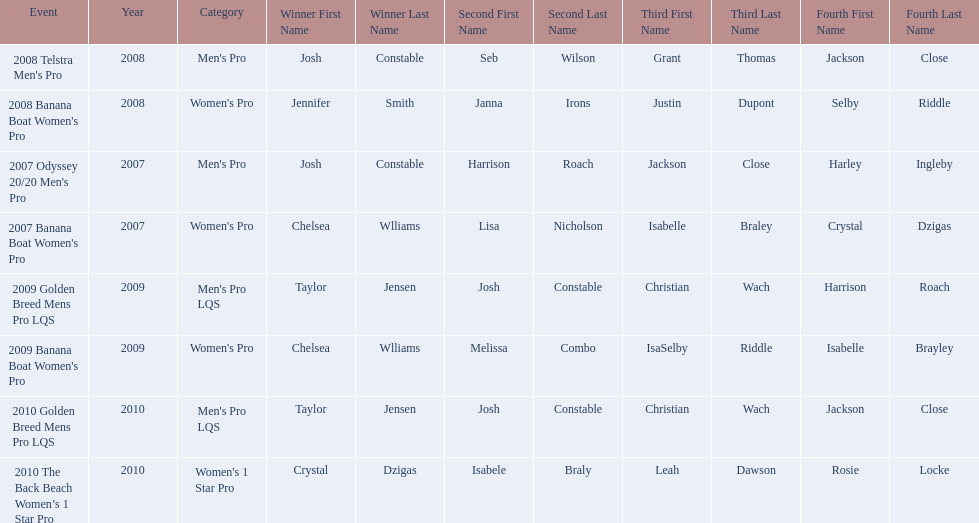At which event did taylor jensen first win? 2009 Golden Breed Mens Pro LQS. 